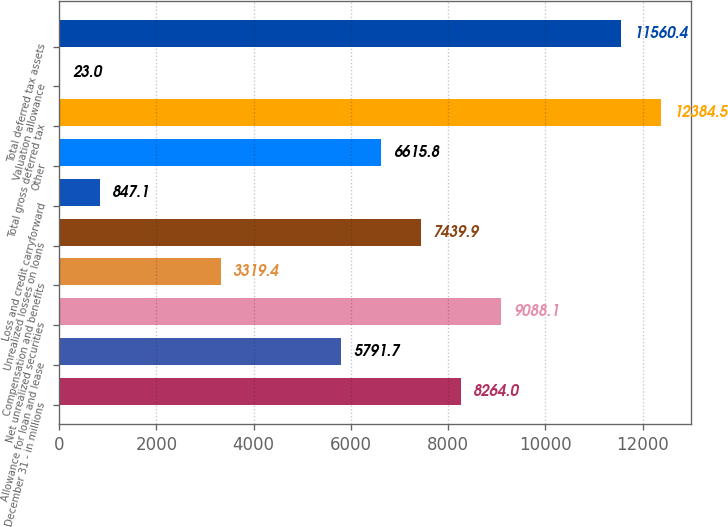<chart> <loc_0><loc_0><loc_500><loc_500><bar_chart><fcel>December 31 - in millions<fcel>Allowance for loan and lease<fcel>Net unrealized securities<fcel>Compensation and benefits<fcel>Unrealized losses on loans<fcel>Loss and credit carryforward<fcel>Other<fcel>Total gross deferred tax<fcel>Valuation allowance<fcel>Total deferred tax assets<nl><fcel>8264<fcel>5791.7<fcel>9088.1<fcel>3319.4<fcel>7439.9<fcel>847.1<fcel>6615.8<fcel>12384.5<fcel>23<fcel>11560.4<nl></chart> 